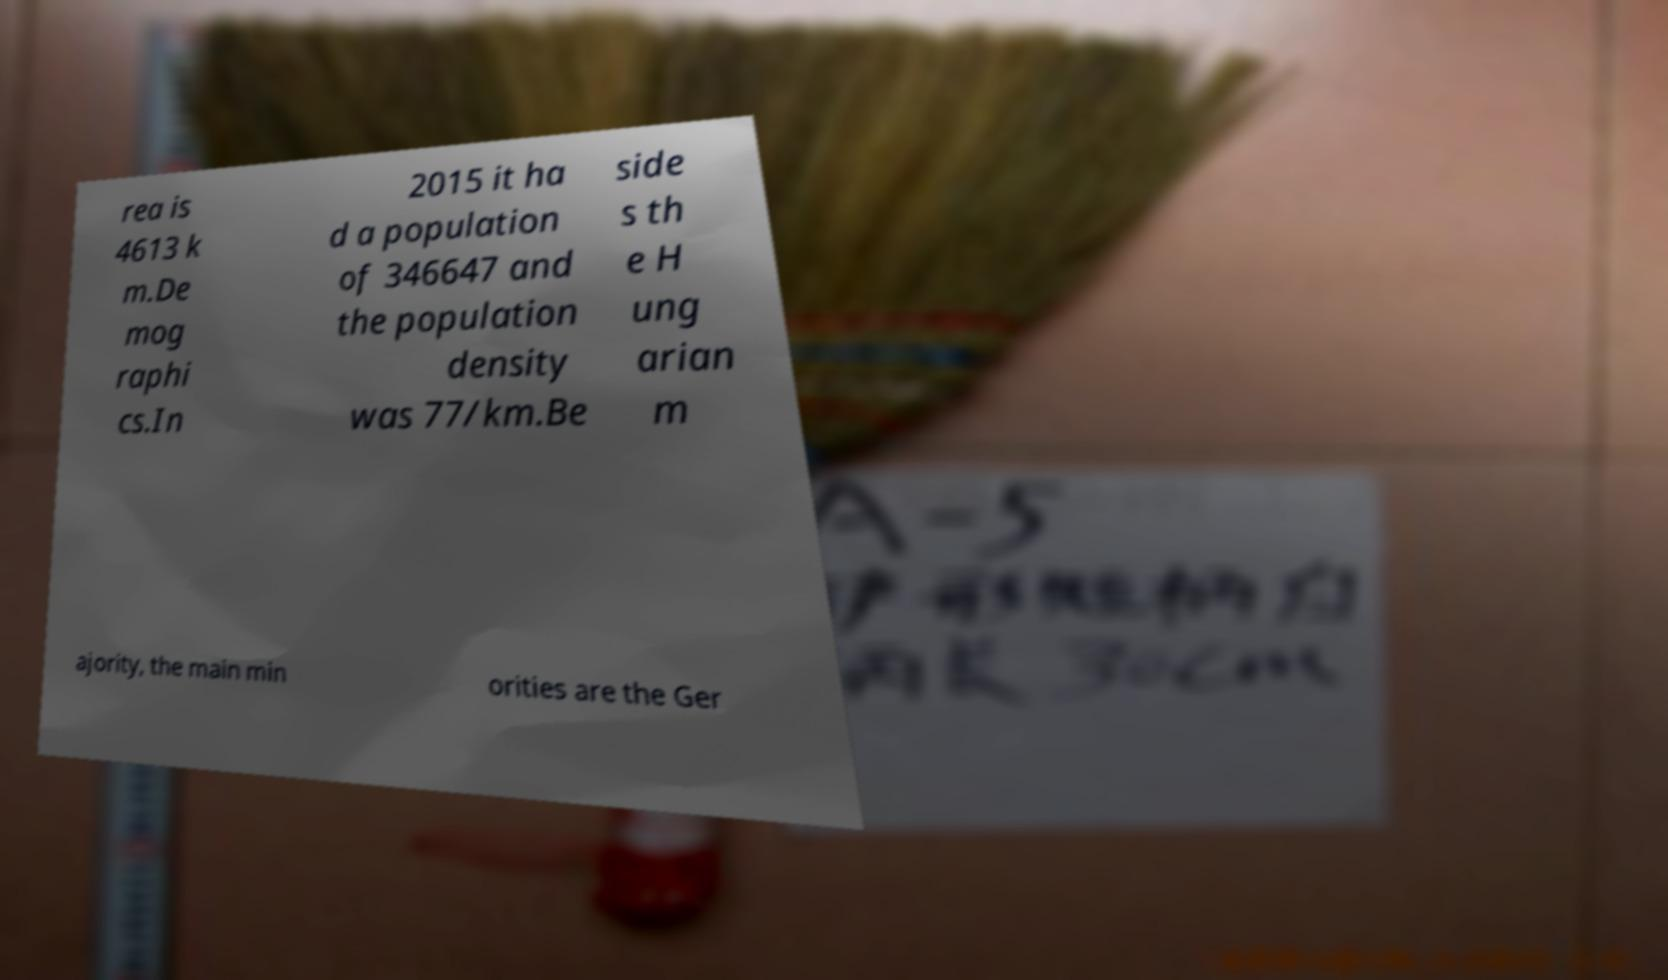Please read and relay the text visible in this image. What does it say? rea is 4613 k m.De mog raphi cs.In 2015 it ha d a population of 346647 and the population density was 77/km.Be side s th e H ung arian m ajority, the main min orities are the Ger 